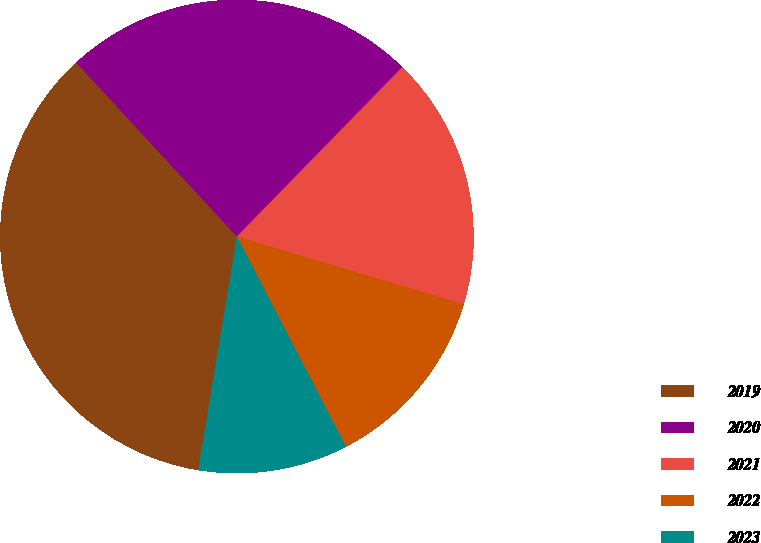<chart> <loc_0><loc_0><loc_500><loc_500><pie_chart><fcel>2019<fcel>2020<fcel>2021<fcel>2022<fcel>2023<nl><fcel>35.52%<fcel>24.18%<fcel>17.31%<fcel>12.76%<fcel>10.23%<nl></chart> 